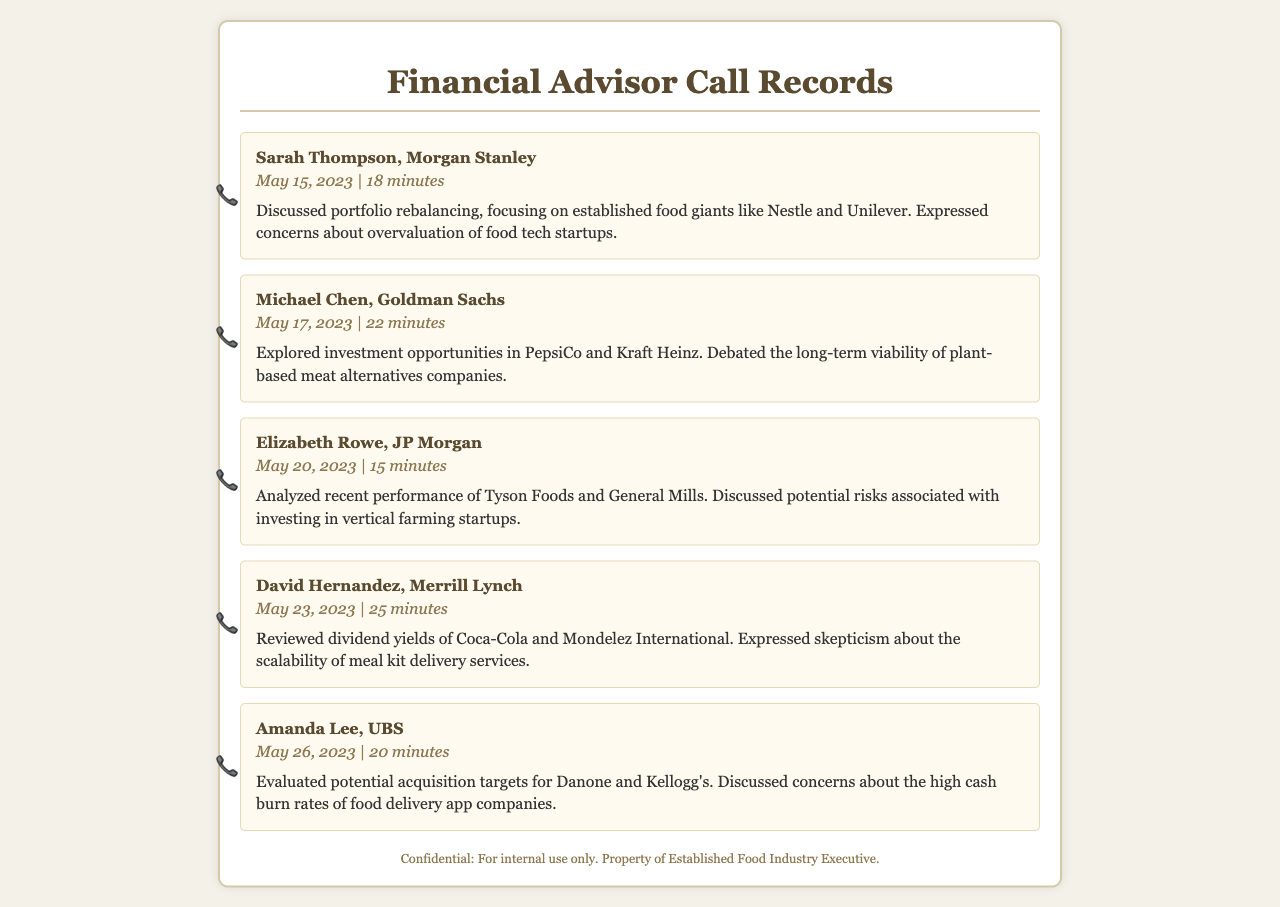What was the duration of the call with Sarah Thompson? The duration of the call with Sarah Thompson is specifically mentioned, which is 18 minutes.
Answer: 18 minutes Which financial advisor discussed PepsiCo? This information can be found by looking at the summary of the relevant call record with Michael Chen.
Answer: Michael Chen What companies were discussed in the call with David Hernandez? The summary of the call with David Hernandez includes Coca-Cola and Mondelez International.
Answer: Coca-Cola and Mondelez International How many minutes was the call with Elizabeth Rowe? The duration of Elizabeth Rowe's call is stated clearly, which is 15 minutes.
Answer: 15 minutes Which food company's acquisition targets were evaluated in the call with Amanda Lee? The summary states that potential acquisition targets for Danone and Kellogg's were evaluated.
Answer: Danone and Kellogg's What were the concerns expressed during the call with Elizabeth Rowe? The summary includes specific concerns regarding risks associated with vertical farming startups.
Answer: Risks associated with vertical farming startups What type of investment strategies were favored in the calls? Throughout the summaries, the discussions favored established food companies over newer startups.
Answer: Established food companies Which calling date had a discussion focused on the overvaluation of food tech startups? The date of the call with Sarah Thompson contained this discussion, which was on May 15, 2023.
Answer: May 15, 2023 